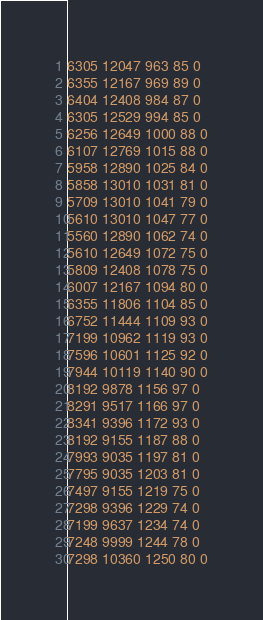Convert code to text. <code><loc_0><loc_0><loc_500><loc_500><_SML_>6305 12047 963 85 0
6355 12167 969 89 0
6404 12408 984 87 0
6305 12529 994 85 0
6256 12649 1000 88 0
6107 12769 1015 88 0
5958 12890 1025 84 0
5858 13010 1031 81 0
5709 13010 1041 79 0
5610 13010 1047 77 0
5560 12890 1062 74 0
5610 12649 1072 75 0
5809 12408 1078 75 0
6007 12167 1094 80 0
6355 11806 1104 85 0
6752 11444 1109 93 0
7199 10962 1119 93 0
7596 10601 1125 92 0
7944 10119 1140 90 0
8192 9878 1156 97 0
8291 9517 1166 97 0
8341 9396 1172 93 0
8192 9155 1187 88 0
7993 9035 1197 81 0
7795 9035 1203 81 0
7497 9155 1219 75 0
7298 9396 1229 74 0
7199 9637 1234 74 0
7248 9999 1244 78 0
7298 10360 1250 80 0</code> 